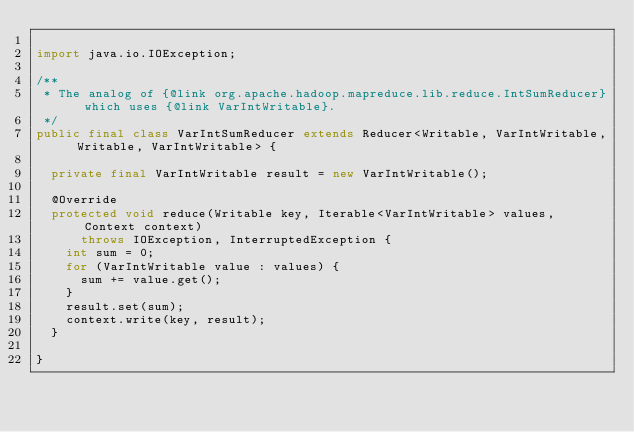Convert code to text. <code><loc_0><loc_0><loc_500><loc_500><_Java_>
import java.io.IOException;

/**
 * The analog of {@link org.apache.hadoop.mapreduce.lib.reduce.IntSumReducer} which uses {@link VarIntWritable}.
 */
public final class VarIntSumReducer extends Reducer<Writable, VarIntWritable, Writable, VarIntWritable> {

  private final VarIntWritable result = new VarIntWritable();

  @Override
  protected void reduce(Writable key, Iterable<VarIntWritable> values, Context context)
      throws IOException, InterruptedException {
    int sum = 0;
    for (VarIntWritable value : values) {
      sum += value.get();
    }
    result.set(sum);
    context.write(key, result);
  }

}
</code> 